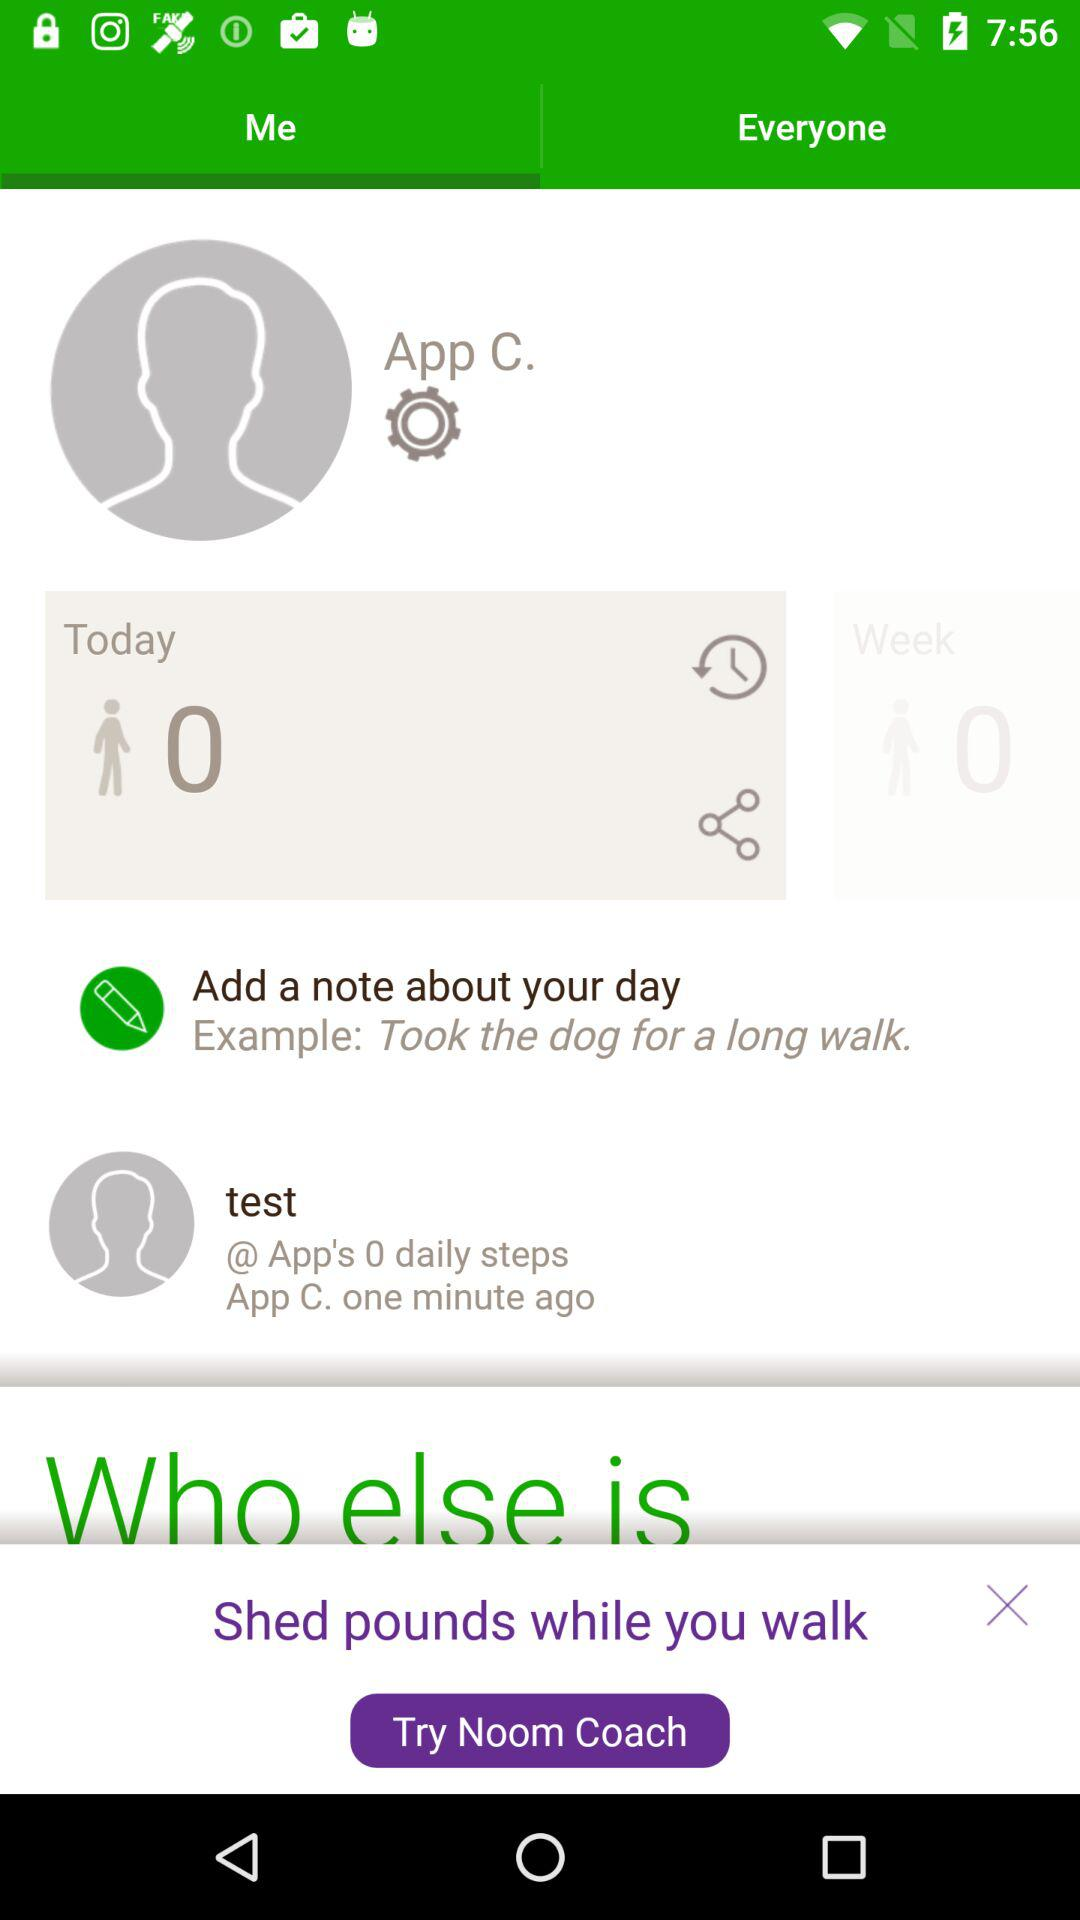How much does the user weigh?
When the provided information is insufficient, respond with <no answer>. <no answer> 